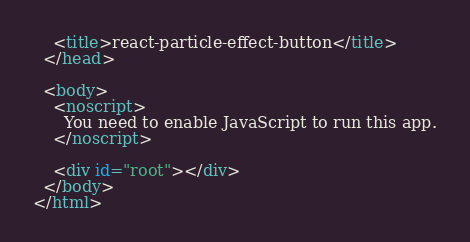<code> <loc_0><loc_0><loc_500><loc_500><_HTML_>    <title>react-particle-effect-button</title>
  </head>

  <body>
    <noscript>
      You need to enable JavaScript to run this app.
    </noscript>

    <div id="root"></div>
  </body>
</html>
</code> 